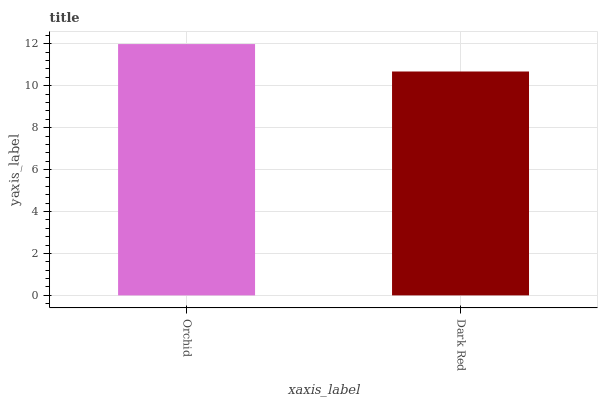Is Dark Red the minimum?
Answer yes or no. Yes. Is Orchid the maximum?
Answer yes or no. Yes. Is Dark Red the maximum?
Answer yes or no. No. Is Orchid greater than Dark Red?
Answer yes or no. Yes. Is Dark Red less than Orchid?
Answer yes or no. Yes. Is Dark Red greater than Orchid?
Answer yes or no. No. Is Orchid less than Dark Red?
Answer yes or no. No. Is Orchid the high median?
Answer yes or no. Yes. Is Dark Red the low median?
Answer yes or no. Yes. Is Dark Red the high median?
Answer yes or no. No. Is Orchid the low median?
Answer yes or no. No. 